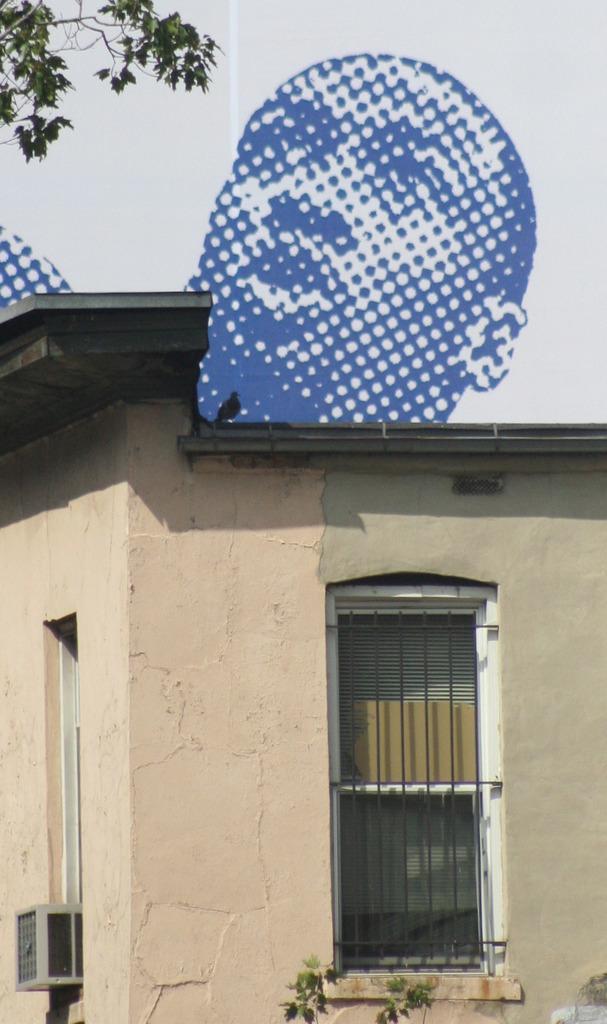How would you summarize this image in a sentence or two? In this picture we can see a small house with a window. In the background, we can see a mosaic image of a person & leaves. 